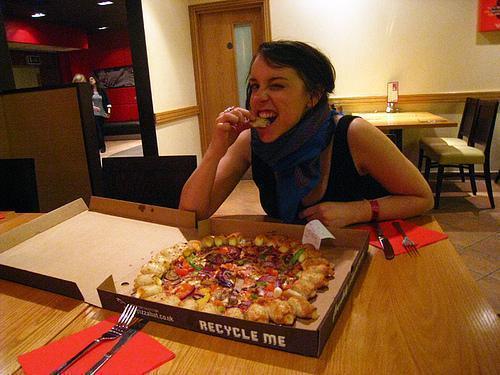Which item here can be turned into something else without eating it?
Select the accurate answer and provide explanation: 'Answer: answer
Rationale: rationale.'
Options: Pizza, nothing, pizza box, woman. Answer: pizza box.
Rationale: The writing on the side of the box indicates that it can be recycled and thus turned into another product in time. 